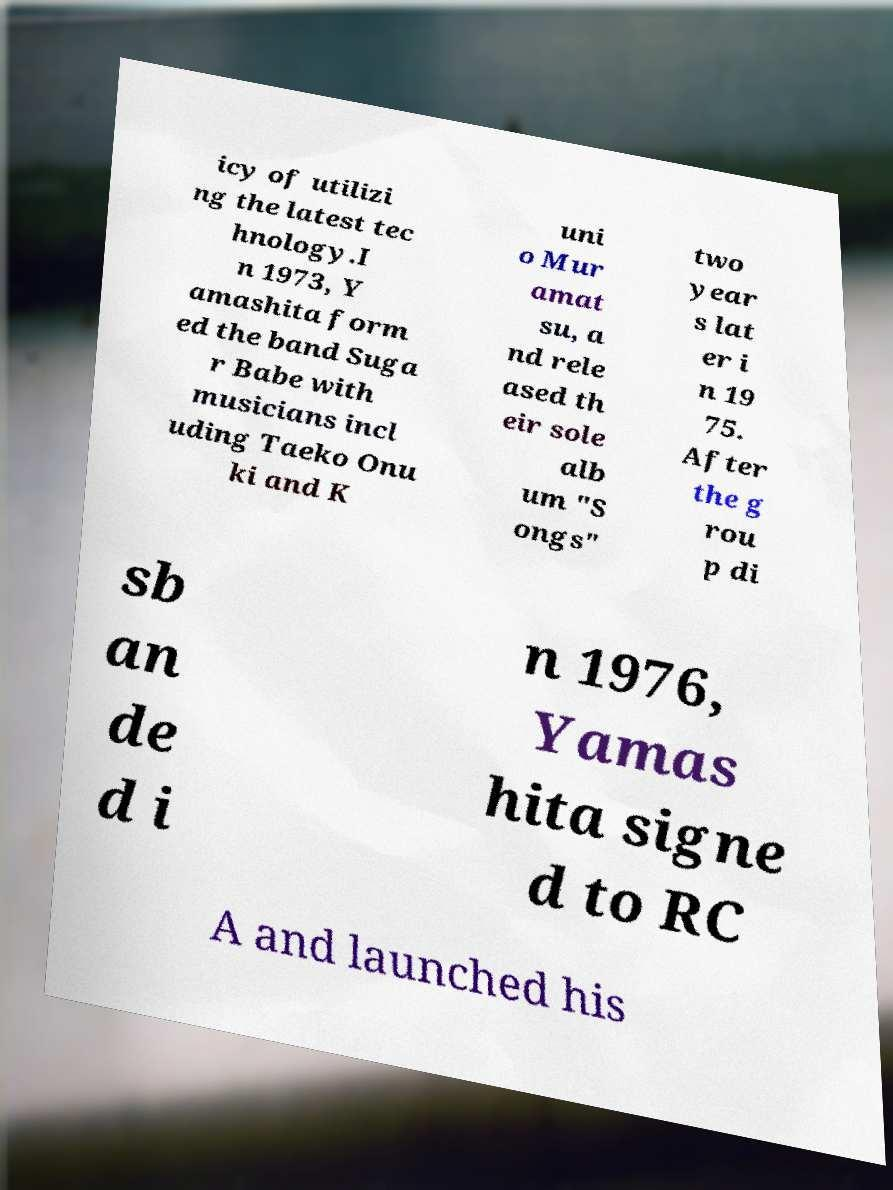Can you accurately transcribe the text from the provided image for me? icy of utilizi ng the latest tec hnology.I n 1973, Y amashita form ed the band Suga r Babe with musicians incl uding Taeko Onu ki and K uni o Mur amat su, a nd rele ased th eir sole alb um "S ongs" two year s lat er i n 19 75. After the g rou p di sb an de d i n 1976, Yamas hita signe d to RC A and launched his 